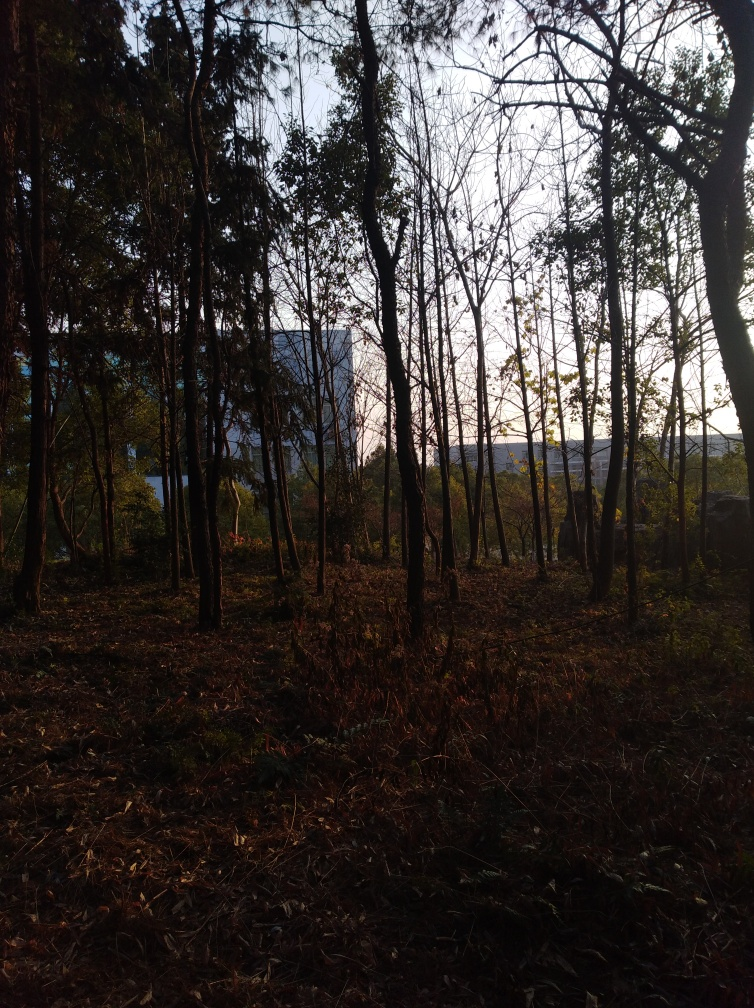Does the photograph suffer from noise/distortion? Upon close inspection of the photograph, it appears to be relatively clear with no significant noise or distortion affecting the quality. The image captures the ethereal beauty of a forest during what seems to be the golden hour, with sunlight filtering through the trees, casting long shadows and giving a warm hue to the scene. It maintains a high level of detail without noticeable visual interference, which often characterizes noise or distortion. 